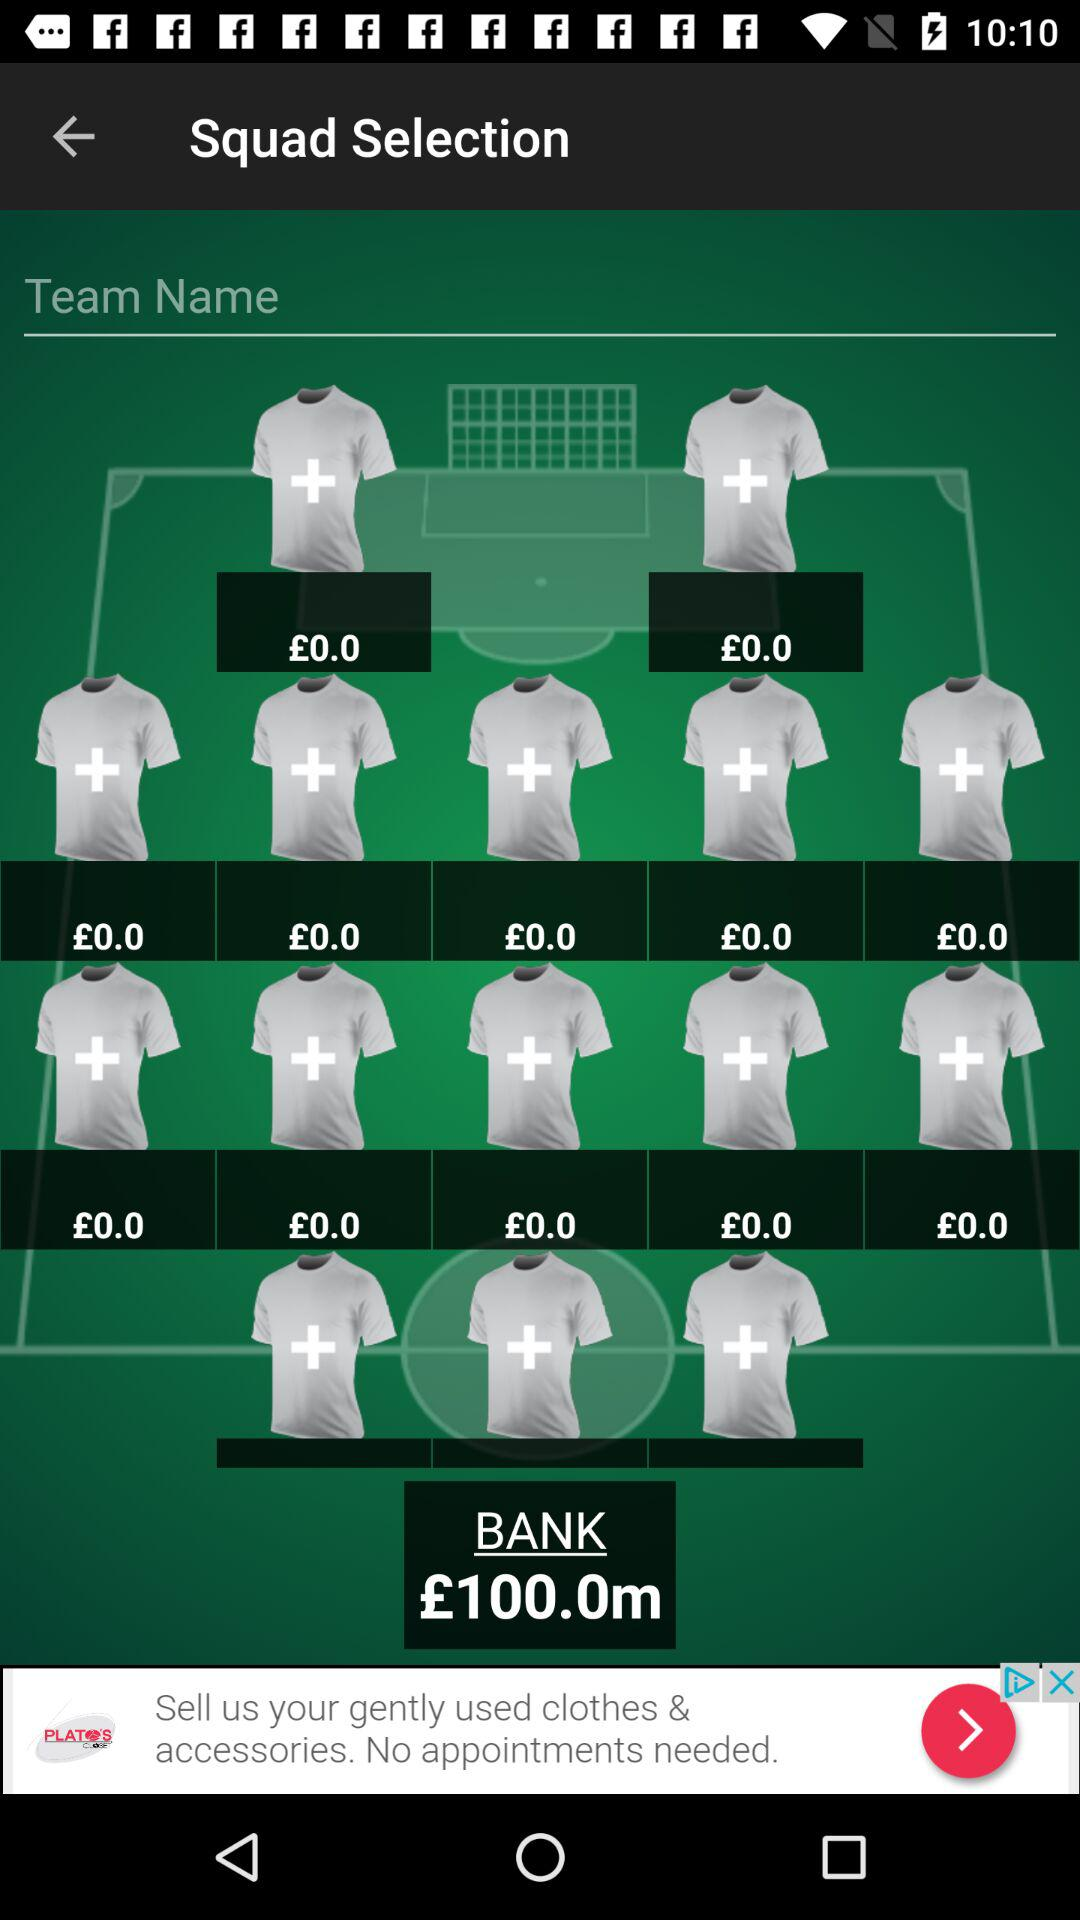What is the total value of all the shirts in the team?
Answer the question using a single word or phrase. £100.0m 